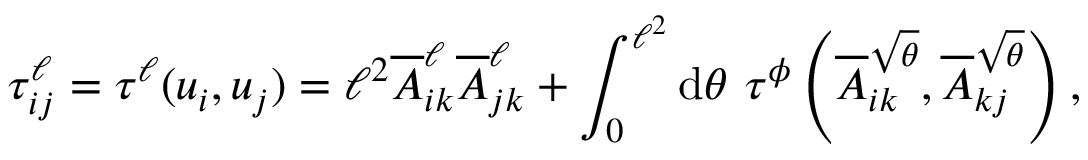Convert formula to latex. <formula><loc_0><loc_0><loc_500><loc_500>\tau _ { i j } ^ { \ell } = \tau ^ { \ell } ( u _ { i } , u _ { j } ) = \ell ^ { 2 } \overline { A } _ { i k } ^ { \ell } \overline { A } _ { j k } ^ { \ell } + \int _ { 0 } ^ { \ell ^ { 2 } } d \theta \tau ^ { \phi } \left ( \overline { A } _ { i k } ^ { \sqrt { \theta } } , \overline { A } _ { k j } ^ { \sqrt { \theta } } \right ) ,</formula> 